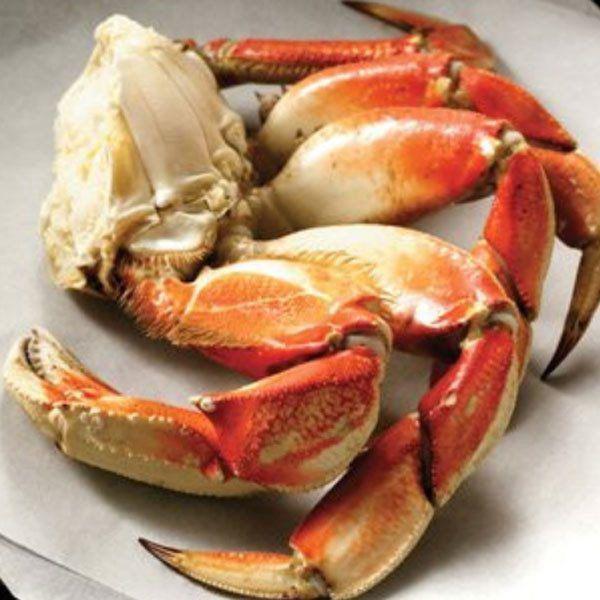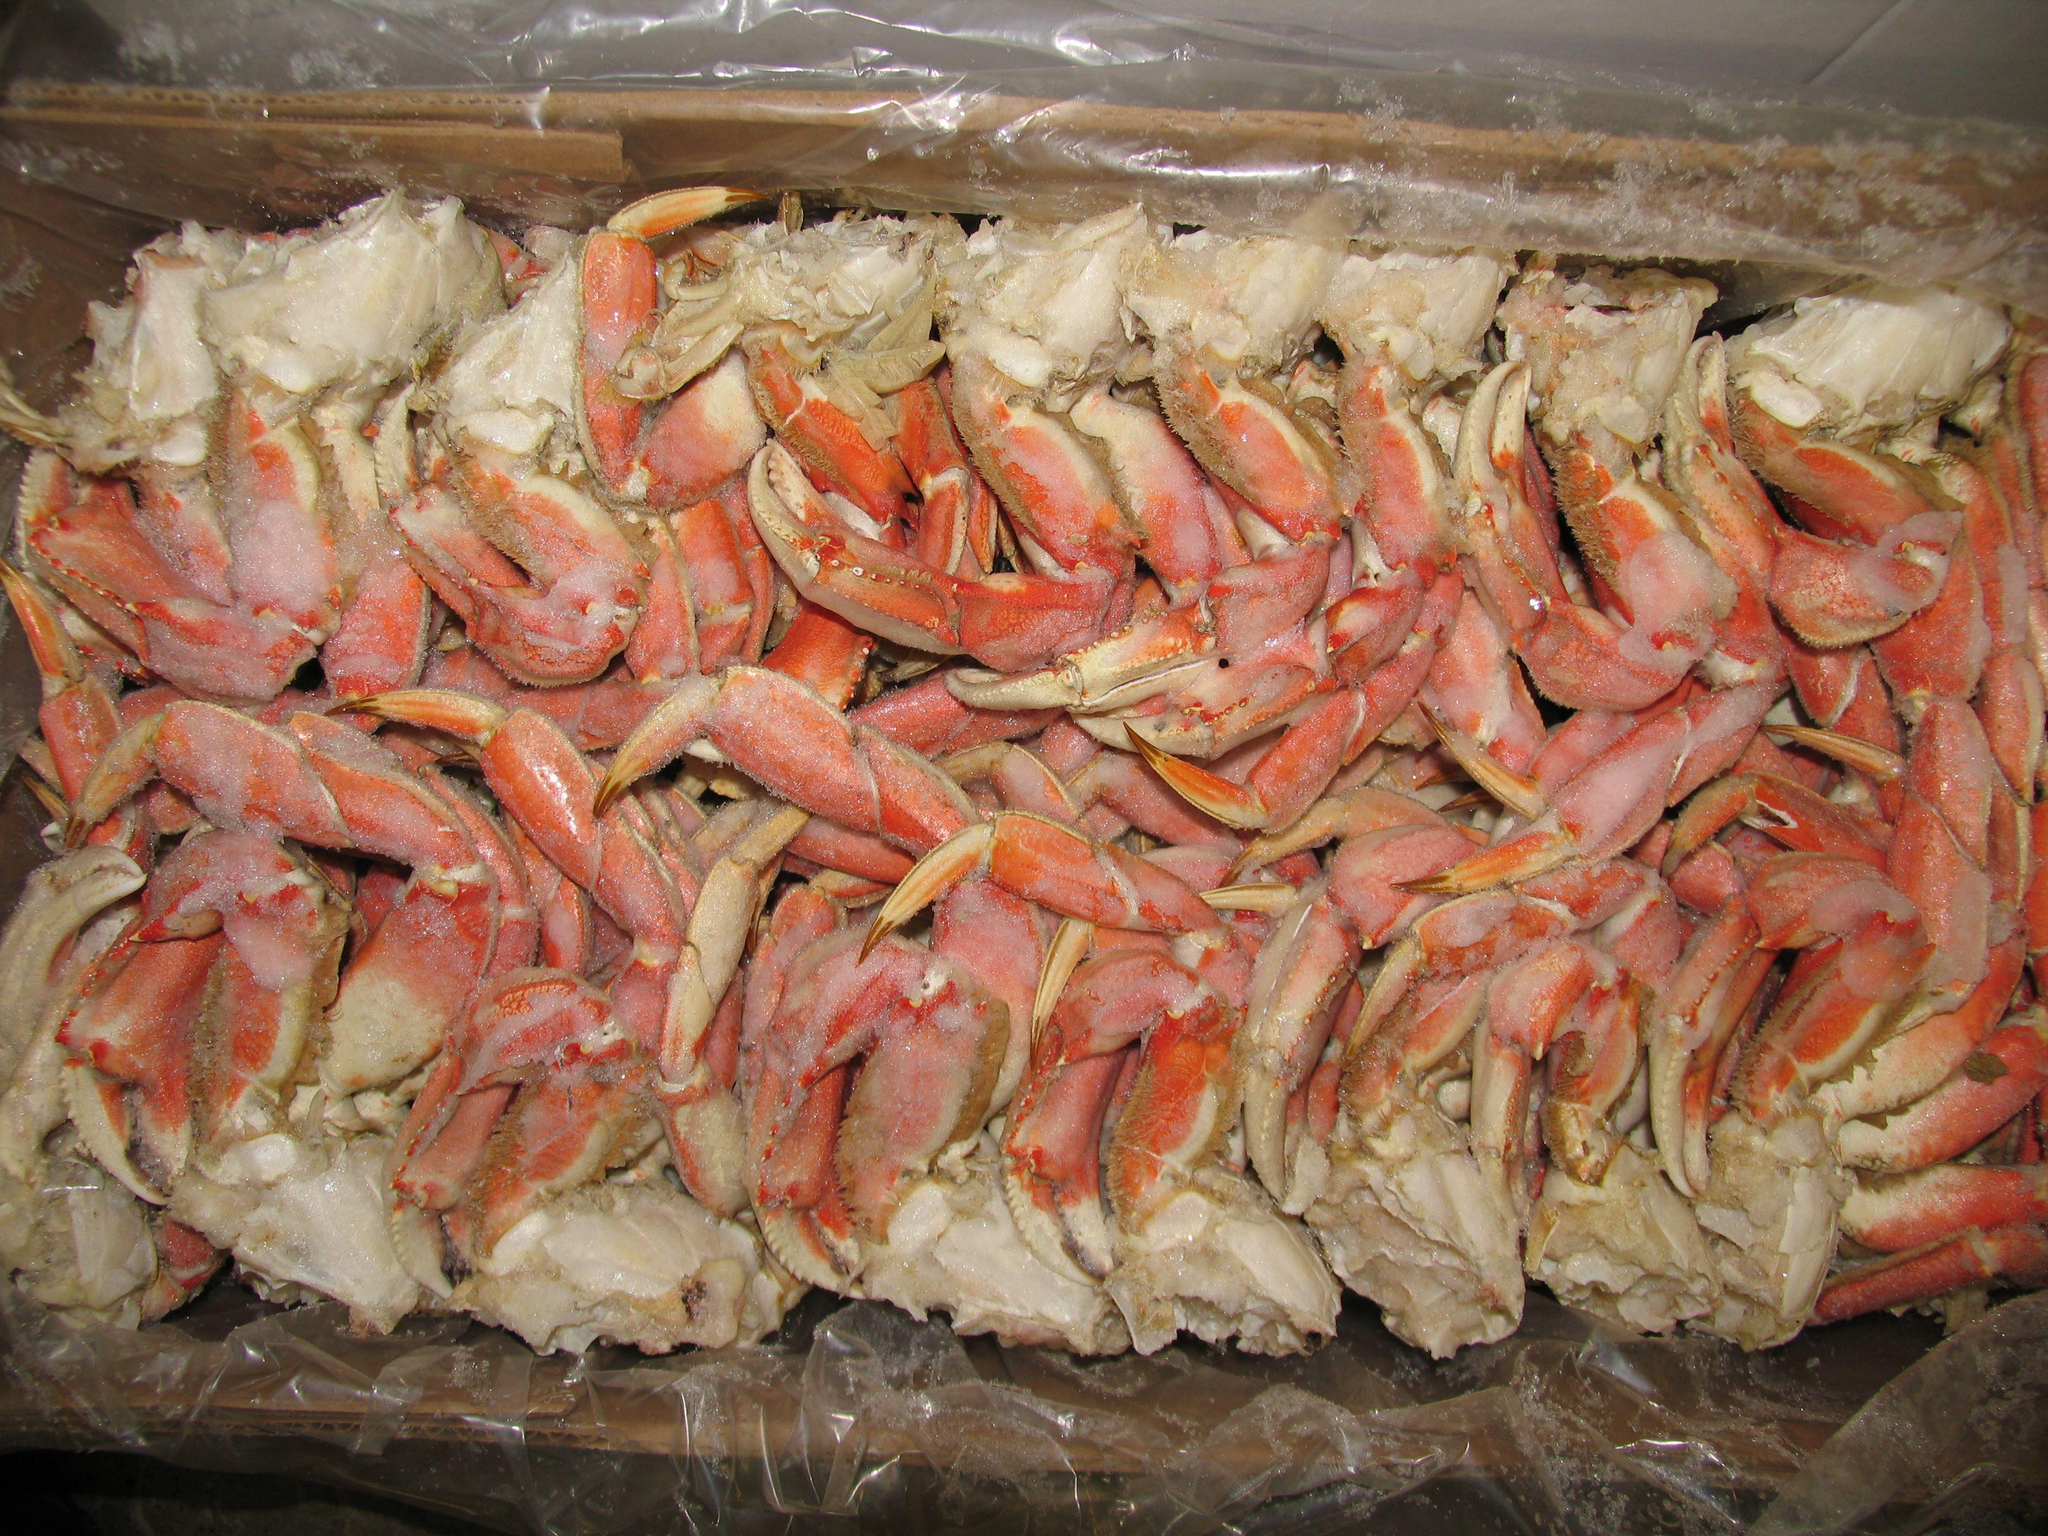The first image is the image on the left, the second image is the image on the right. Assess this claim about the two images: "In at least one image there is a total of five crab legs.". Correct or not? Answer yes or no. Yes. 